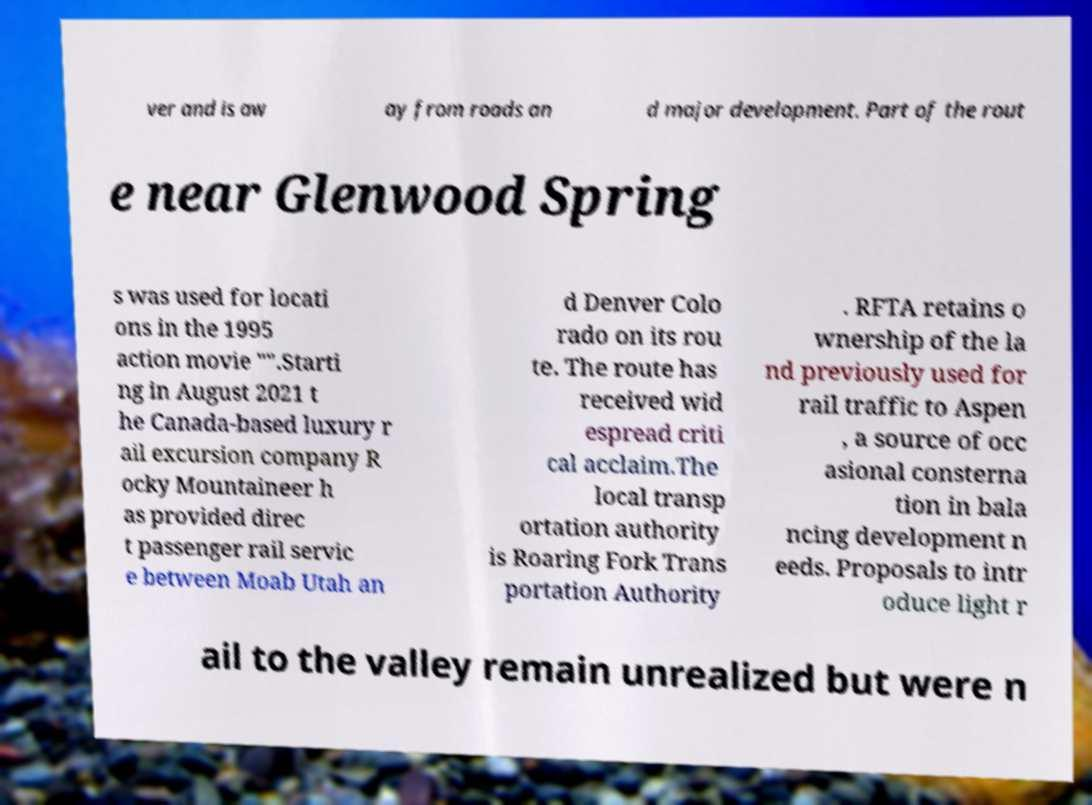Please read and relay the text visible in this image. What does it say? ver and is aw ay from roads an d major development. Part of the rout e near Glenwood Spring s was used for locati ons in the 1995 action movie "".Starti ng in August 2021 t he Canada-based luxury r ail excursion company R ocky Mountaineer h as provided direc t passenger rail servic e between Moab Utah an d Denver Colo rado on its rou te. The route has received wid espread criti cal acclaim.The local transp ortation authority is Roaring Fork Trans portation Authority . RFTA retains o wnership of the la nd previously used for rail traffic to Aspen , a source of occ asional consterna tion in bala ncing development n eeds. Proposals to intr oduce light r ail to the valley remain unrealized but were n 